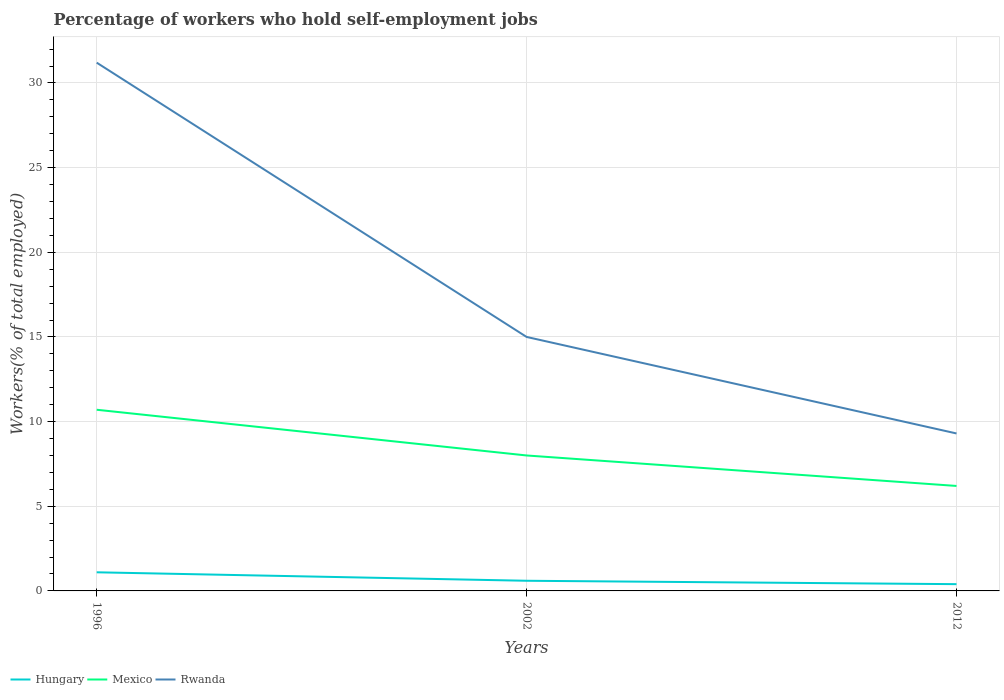Does the line corresponding to Hungary intersect with the line corresponding to Mexico?
Your answer should be very brief. No. Across all years, what is the maximum percentage of self-employed workers in Hungary?
Your response must be concise. 0.4. What is the total percentage of self-employed workers in Hungary in the graph?
Your answer should be very brief. 0.7. What is the difference between the highest and the second highest percentage of self-employed workers in Rwanda?
Your response must be concise. 21.9. What is the difference between two consecutive major ticks on the Y-axis?
Your answer should be very brief. 5. Are the values on the major ticks of Y-axis written in scientific E-notation?
Your answer should be very brief. No. How many legend labels are there?
Offer a very short reply. 3. What is the title of the graph?
Keep it short and to the point. Percentage of workers who hold self-employment jobs. Does "Madagascar" appear as one of the legend labels in the graph?
Your answer should be very brief. No. What is the label or title of the X-axis?
Provide a short and direct response. Years. What is the label or title of the Y-axis?
Keep it short and to the point. Workers(% of total employed). What is the Workers(% of total employed) of Hungary in 1996?
Offer a terse response. 1.1. What is the Workers(% of total employed) of Mexico in 1996?
Ensure brevity in your answer.  10.7. What is the Workers(% of total employed) in Rwanda in 1996?
Your answer should be compact. 31.2. What is the Workers(% of total employed) of Hungary in 2002?
Offer a terse response. 0.6. What is the Workers(% of total employed) of Mexico in 2002?
Your response must be concise. 8. What is the Workers(% of total employed) of Hungary in 2012?
Your response must be concise. 0.4. What is the Workers(% of total employed) of Mexico in 2012?
Provide a succinct answer. 6.2. What is the Workers(% of total employed) in Rwanda in 2012?
Your answer should be very brief. 9.3. Across all years, what is the maximum Workers(% of total employed) of Hungary?
Your answer should be compact. 1.1. Across all years, what is the maximum Workers(% of total employed) in Mexico?
Make the answer very short. 10.7. Across all years, what is the maximum Workers(% of total employed) of Rwanda?
Ensure brevity in your answer.  31.2. Across all years, what is the minimum Workers(% of total employed) of Hungary?
Ensure brevity in your answer.  0.4. Across all years, what is the minimum Workers(% of total employed) in Mexico?
Give a very brief answer. 6.2. Across all years, what is the minimum Workers(% of total employed) in Rwanda?
Keep it short and to the point. 9.3. What is the total Workers(% of total employed) of Hungary in the graph?
Offer a very short reply. 2.1. What is the total Workers(% of total employed) of Mexico in the graph?
Provide a succinct answer. 24.9. What is the total Workers(% of total employed) of Rwanda in the graph?
Offer a very short reply. 55.5. What is the difference between the Workers(% of total employed) in Mexico in 1996 and that in 2002?
Ensure brevity in your answer.  2.7. What is the difference between the Workers(% of total employed) of Hungary in 1996 and that in 2012?
Offer a terse response. 0.7. What is the difference between the Workers(% of total employed) in Mexico in 1996 and that in 2012?
Provide a short and direct response. 4.5. What is the difference between the Workers(% of total employed) in Rwanda in 1996 and that in 2012?
Offer a very short reply. 21.9. What is the difference between the Workers(% of total employed) in Mexico in 2002 and that in 2012?
Ensure brevity in your answer.  1.8. What is the difference between the Workers(% of total employed) in Rwanda in 2002 and that in 2012?
Your response must be concise. 5.7. What is the difference between the Workers(% of total employed) of Mexico in 1996 and the Workers(% of total employed) of Rwanda in 2002?
Keep it short and to the point. -4.3. What is the difference between the Workers(% of total employed) in Hungary in 1996 and the Workers(% of total employed) in Mexico in 2012?
Your answer should be very brief. -5.1. What is the difference between the Workers(% of total employed) of Hungary in 2002 and the Workers(% of total employed) of Mexico in 2012?
Offer a terse response. -5.6. What is the difference between the Workers(% of total employed) of Mexico in 2002 and the Workers(% of total employed) of Rwanda in 2012?
Provide a succinct answer. -1.3. What is the average Workers(% of total employed) in Hungary per year?
Make the answer very short. 0.7. What is the average Workers(% of total employed) in Mexico per year?
Offer a very short reply. 8.3. What is the average Workers(% of total employed) in Rwanda per year?
Provide a short and direct response. 18.5. In the year 1996, what is the difference between the Workers(% of total employed) of Hungary and Workers(% of total employed) of Rwanda?
Give a very brief answer. -30.1. In the year 1996, what is the difference between the Workers(% of total employed) of Mexico and Workers(% of total employed) of Rwanda?
Give a very brief answer. -20.5. In the year 2002, what is the difference between the Workers(% of total employed) of Hungary and Workers(% of total employed) of Rwanda?
Your answer should be compact. -14.4. In the year 2012, what is the difference between the Workers(% of total employed) of Hungary and Workers(% of total employed) of Mexico?
Provide a succinct answer. -5.8. What is the ratio of the Workers(% of total employed) in Hungary in 1996 to that in 2002?
Give a very brief answer. 1.83. What is the ratio of the Workers(% of total employed) of Mexico in 1996 to that in 2002?
Give a very brief answer. 1.34. What is the ratio of the Workers(% of total employed) of Rwanda in 1996 to that in 2002?
Give a very brief answer. 2.08. What is the ratio of the Workers(% of total employed) of Hungary in 1996 to that in 2012?
Your response must be concise. 2.75. What is the ratio of the Workers(% of total employed) in Mexico in 1996 to that in 2012?
Make the answer very short. 1.73. What is the ratio of the Workers(% of total employed) in Rwanda in 1996 to that in 2012?
Offer a terse response. 3.35. What is the ratio of the Workers(% of total employed) of Mexico in 2002 to that in 2012?
Ensure brevity in your answer.  1.29. What is the ratio of the Workers(% of total employed) in Rwanda in 2002 to that in 2012?
Keep it short and to the point. 1.61. What is the difference between the highest and the lowest Workers(% of total employed) of Rwanda?
Keep it short and to the point. 21.9. 